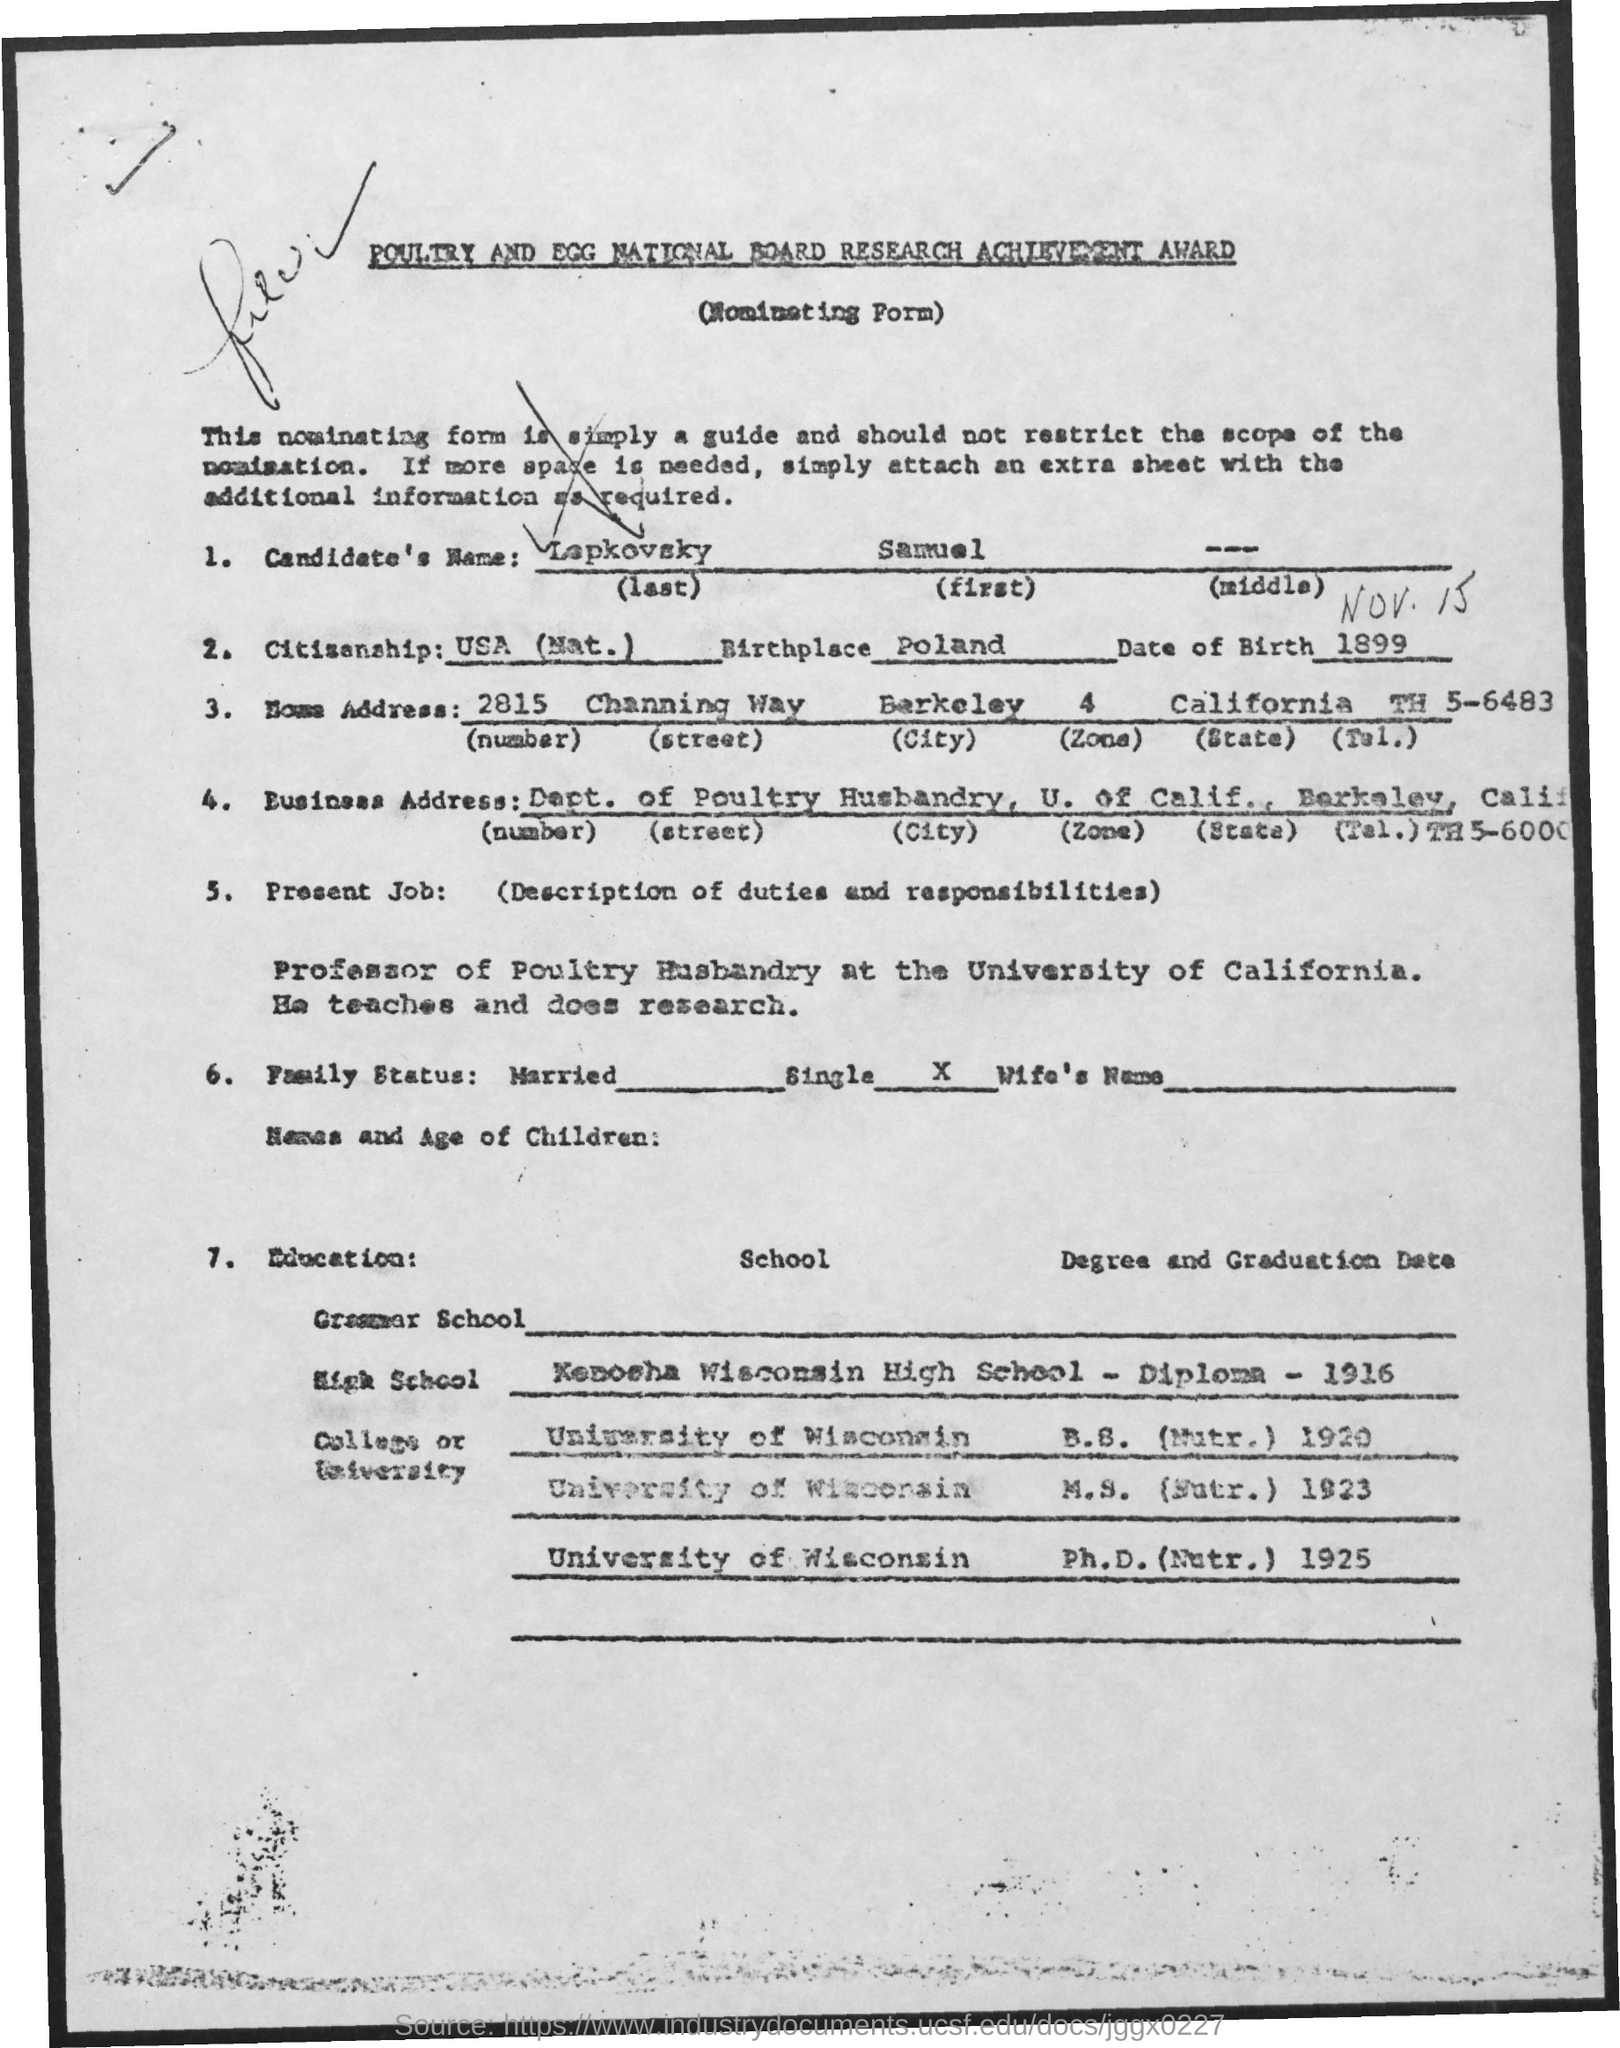Indicate a few pertinent items in this graphic. The candidate's first name is Samuel. The birthplace mentioned in the form is Poland. 